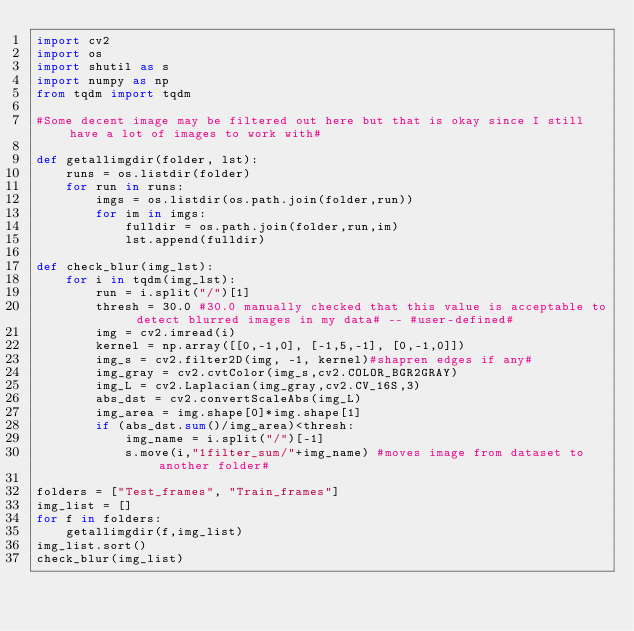Convert code to text. <code><loc_0><loc_0><loc_500><loc_500><_Python_>import cv2
import os
import shutil as s
import numpy as np
from tqdm import tqdm

#Some decent image may be filtered out here but that is okay since I still have a lot of images to work with#

def getallimgdir(folder, lst):
    runs = os.listdir(folder)
    for run in runs:
        imgs = os.listdir(os.path.join(folder,run))
        for im in imgs:
            fulldir = os.path.join(folder,run,im)
            lst.append(fulldir)

def check_blur(img_lst):
    for i in tqdm(img_lst):
        run = i.split("/")[1]
        thresh = 30.0 #30.0 manually checked that this value is acceptable to detect blurred images in my data# -- #user-defined#
        img = cv2.imread(i)
        kernel = np.array([[0,-1,0], [-1,5,-1], [0,-1,0]])
        img_s = cv2.filter2D(img, -1, kernel)#shapren edges if any#
        img_gray = cv2.cvtColor(img_s,cv2.COLOR_BGR2GRAY)
        img_L = cv2.Laplacian(img_gray,cv2.CV_16S,3)
        abs_dst = cv2.convertScaleAbs(img_L)
        img_area = img.shape[0]*img.shape[1]
        if (abs_dst.sum()/img_area)<thresh:
            img_name = i.split("/")[-1]
            s.move(i,"1filter_sum/"+img_name) #moves image from dataset to another folder#

folders = ["Test_frames", "Train_frames"]
img_list = []
for f in folders:
    getallimgdir(f,img_list)
img_list.sort()
check_blur(img_list)





</code> 